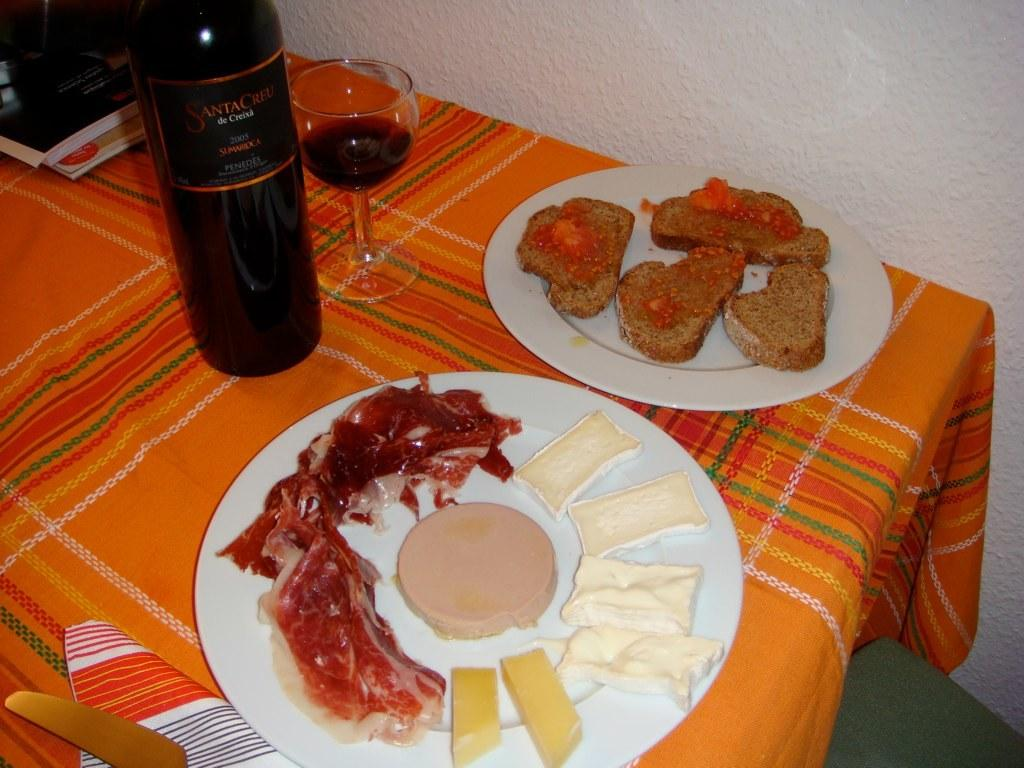<image>
Write a terse but informative summary of the picture. Santa Cruz de Creisa 2005 wine bottle right behind a cheese and prosciutto plate and toast with jam on another. 